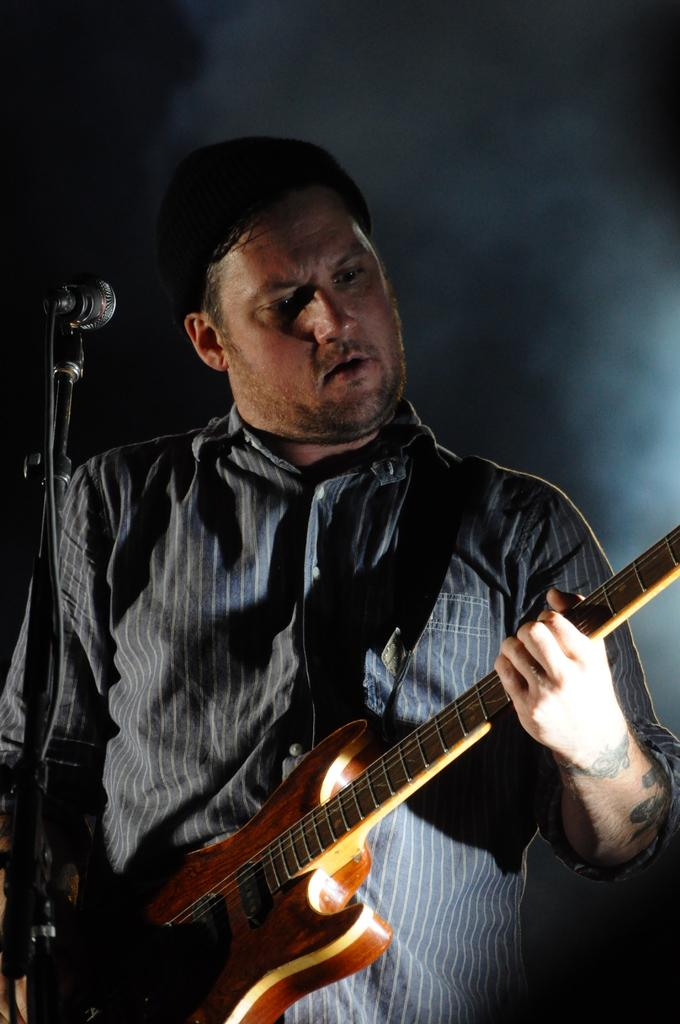Who is the main subject in the image? There is a man in the image. What is the man doing in the image? The man is playing a guitar. What object is present in the image that is typically used for amplifying sound? There is a microphone in the image. What type of lock is visible on the man's apparel in the image? There is no lock visible on the man's apparel in the image. How many beans are present on the man's guitar in the image? There are no beans present on the man's guitar in the image. 